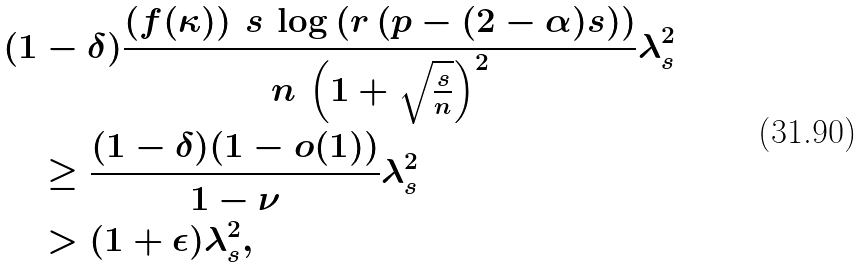<formula> <loc_0><loc_0><loc_500><loc_500>& ( 1 - \delta ) \frac { \left ( f ( \kappa ) \right ) \, s \, \log \left ( r \left ( p - ( 2 - \alpha ) s \right ) \right ) } { n \, \left ( 1 + \sqrt { \frac { s } { n } } \right ) ^ { 2 } } \lambda _ { s } ^ { 2 } \\ & \quad \geq \frac { ( 1 - \delta ) ( 1 - o ( 1 ) ) } { 1 - \nu } \lambda _ { s } ^ { 2 } \\ & \quad > ( 1 + \epsilon ) \lambda _ { s } ^ { 2 } ,</formula> 